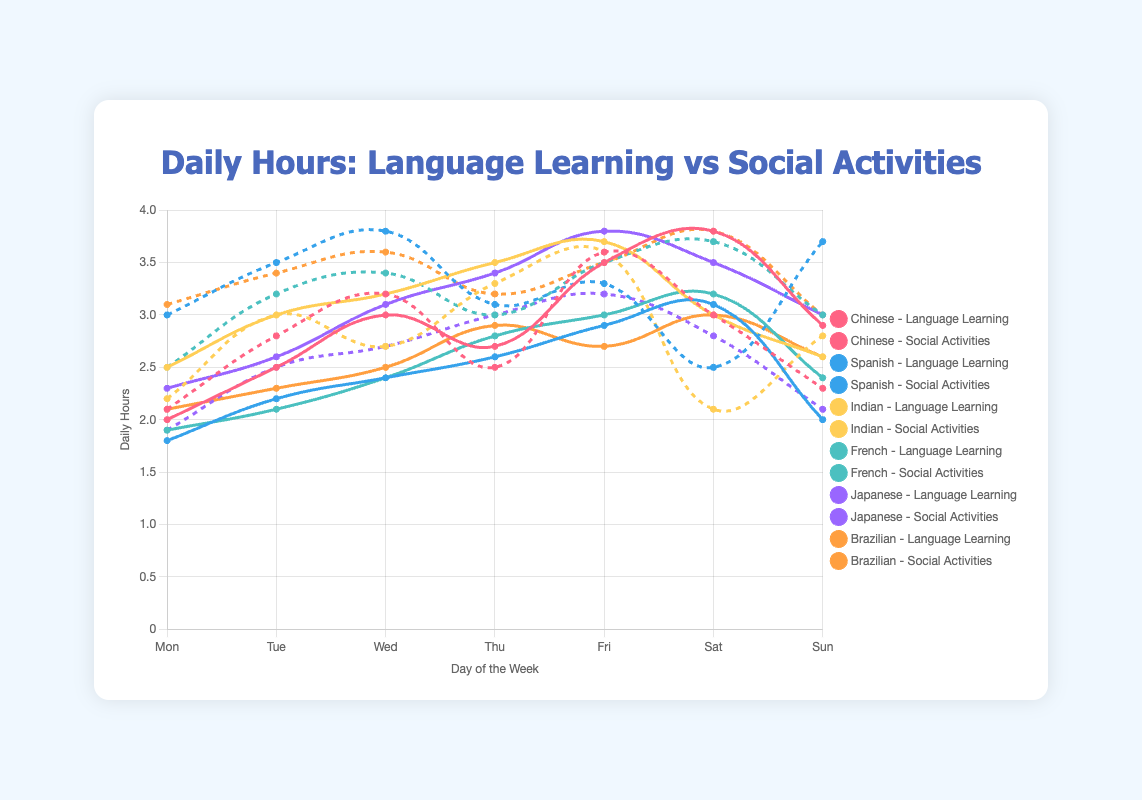What nationality spends the most hours on language learning on Thursday? Look at the line plot for each nationality on Thursday. The peak time for language learning on Thursday is shown by the highest data point on the plots. The Indian group spends 3.5 hours, which is the maximum.
Answer: Indian Which nationality has the least variation in hours spent on social activities throughout the week? Compare the range of hours spent on social activities for each nationality by looking at the difference between the highest and lowest points. The Japanese group has the least variation, with a range of 3.2 - 1.9 = 1.3 hours.
Answer: Japanese On which day do the Chinese spend the most time on social activities? Look at the plot for the Chinese nationality and identify the day with the highest data point for social activities. The highest is on Friday with 3.6 hours.
Answer: Friday What is the average daily time spent on language learning by the Brazilian group? Add up the daily hours spent on language learning by Brazilian students and divide by the number of days. (2.1 + 2.3 + 2.5 + 2.9 + 2.7 + 3.0 + 2.6) / 7 = 2.7286 ≈ 2.73 hours.
Answer: 2.73 Which group shows the highest peak in daily hours spent on social activities, and on what day? Look for the highest peak across all social activities plots. The Spanish group shows the highest peak of 3.8 hours on Wednesday.
Answer: Spanish on Wednesday How does the daily time spent on language learning by the French compare to that of the Japanese on Saturday? Look at the Saturday data points for both nationalities. The French spend 3.2 hours, while the Japanese spend 3.5 hours, so the Japanese spend more.
Answer: The Japanese spend more What is the cumulative total time that the Indian group spends on language learning from Monday to Sunday? Sum the hours spent on language learning each day. 2.5 + 3.0 + 3.2 + 3.5 + 3.7 + 3.0 + 2.6 = 21.5 hours.
Answer: 21.5 hours Which two nationalities spend equal time on social activities on Friday? Compare the hours spent on social activities on Friday for all groups. Both the Chinese and Brazilian nationalities spend 3.6 hours.
Answer: Chinese and Brazilian What is the combined average daily time spent on social activities by the Chinese and Spanish groups? Calculate the average daily time for each group, add them together, and then divide by 2. Chinese: (2.1 + 2.8 + 3.2 + 2.5 + 3.6 + 3.0 + 2.3) / 7 = 2.785; Spanish: (3.0 + 3.5 + 3.8 + 3.1 + 3.3 + 2.5 + 3.7) / 7 = 3.271; Combined average = (2.785 + 3.271) / 2 = 3.028.
Answer: 3.03 